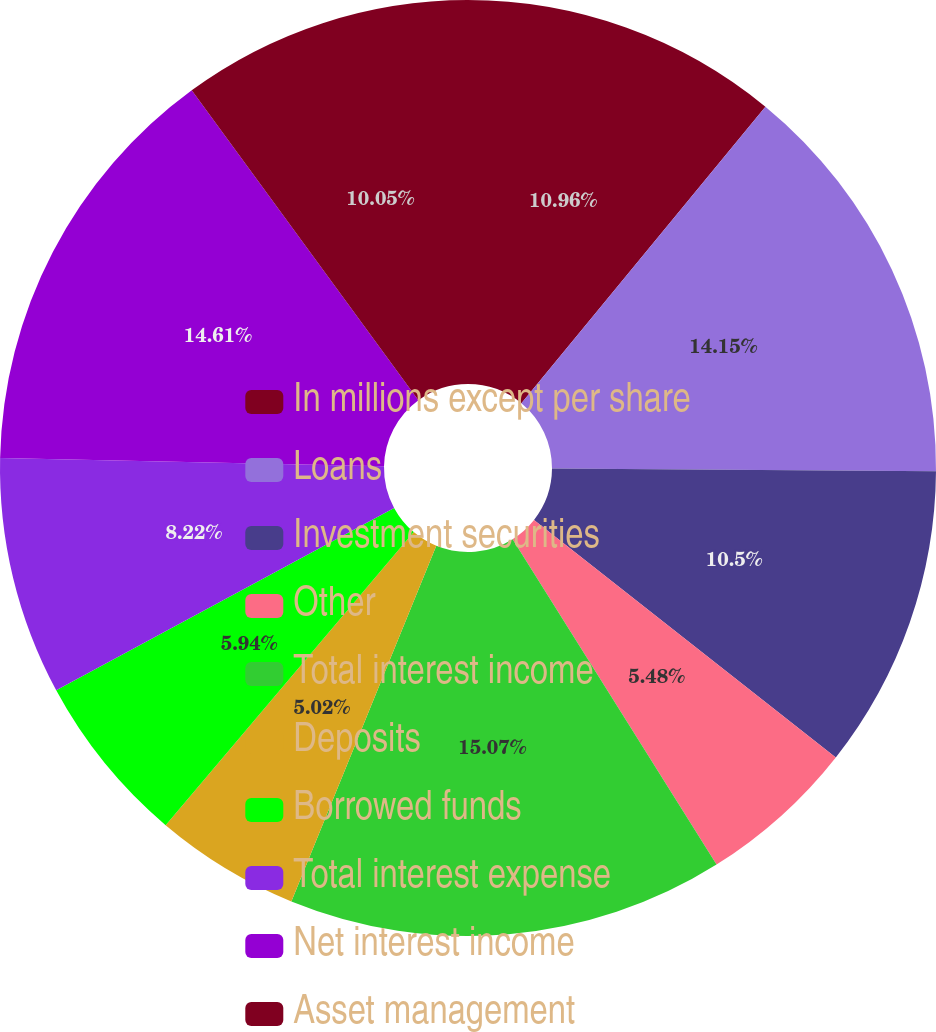<chart> <loc_0><loc_0><loc_500><loc_500><pie_chart><fcel>In millions except per share<fcel>Loans<fcel>Investment securities<fcel>Other<fcel>Total interest income<fcel>Deposits<fcel>Borrowed funds<fcel>Total interest expense<fcel>Net interest income<fcel>Asset management<nl><fcel>10.96%<fcel>14.15%<fcel>10.5%<fcel>5.48%<fcel>15.07%<fcel>5.02%<fcel>5.94%<fcel>8.22%<fcel>14.61%<fcel>10.05%<nl></chart> 